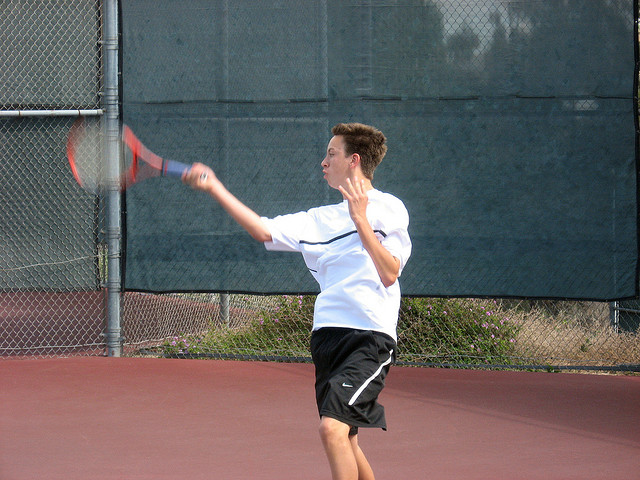<image>What image appears on the tennis player's shirt? I don't know what image appears on the tennis player's shirt. It could be a line or stripe. What image appears on the tennis player's shirt? I don't know what image appears on the tennis player's shirt. It can be seen 'line', 'none', 'nike check', 'stripe', or 'blue line'. 